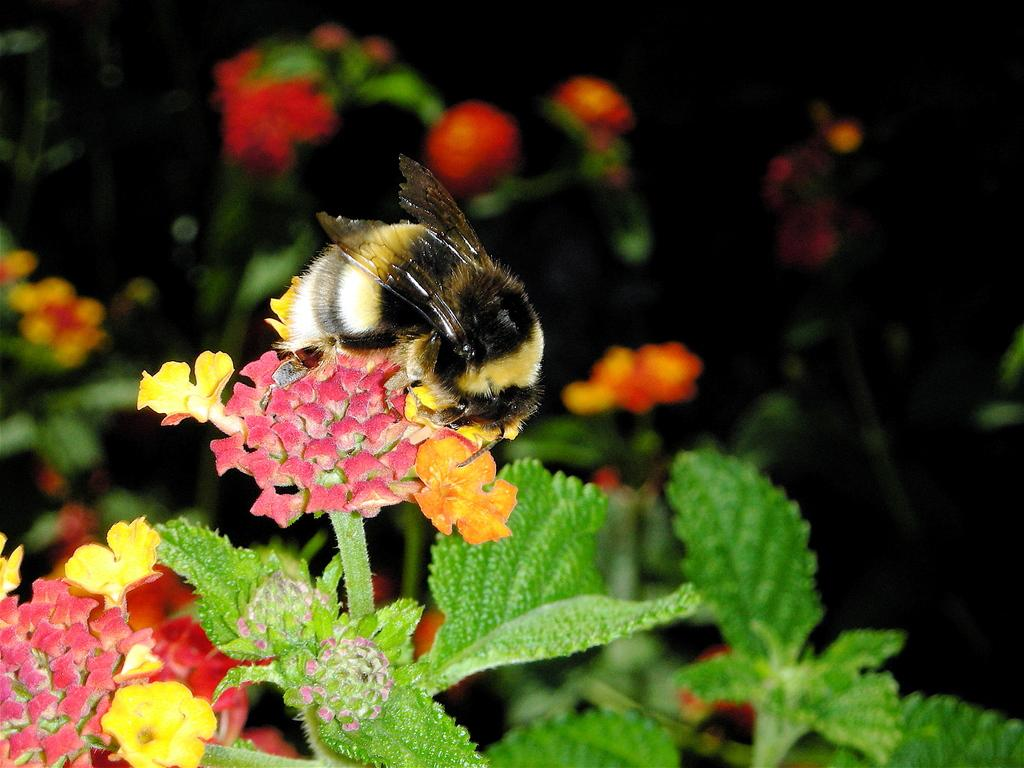What type of insect is present in the image? There is a honey bee in the image. What type of plants can be seen in the image? There are plants with flowers in the image. How would you describe the background of the image? The background of the image is dark. How many tomatoes are hanging from the honey bee's legs in the image? There are no tomatoes present in the image, and the honey bee is not carrying any tomatoes on its legs. 